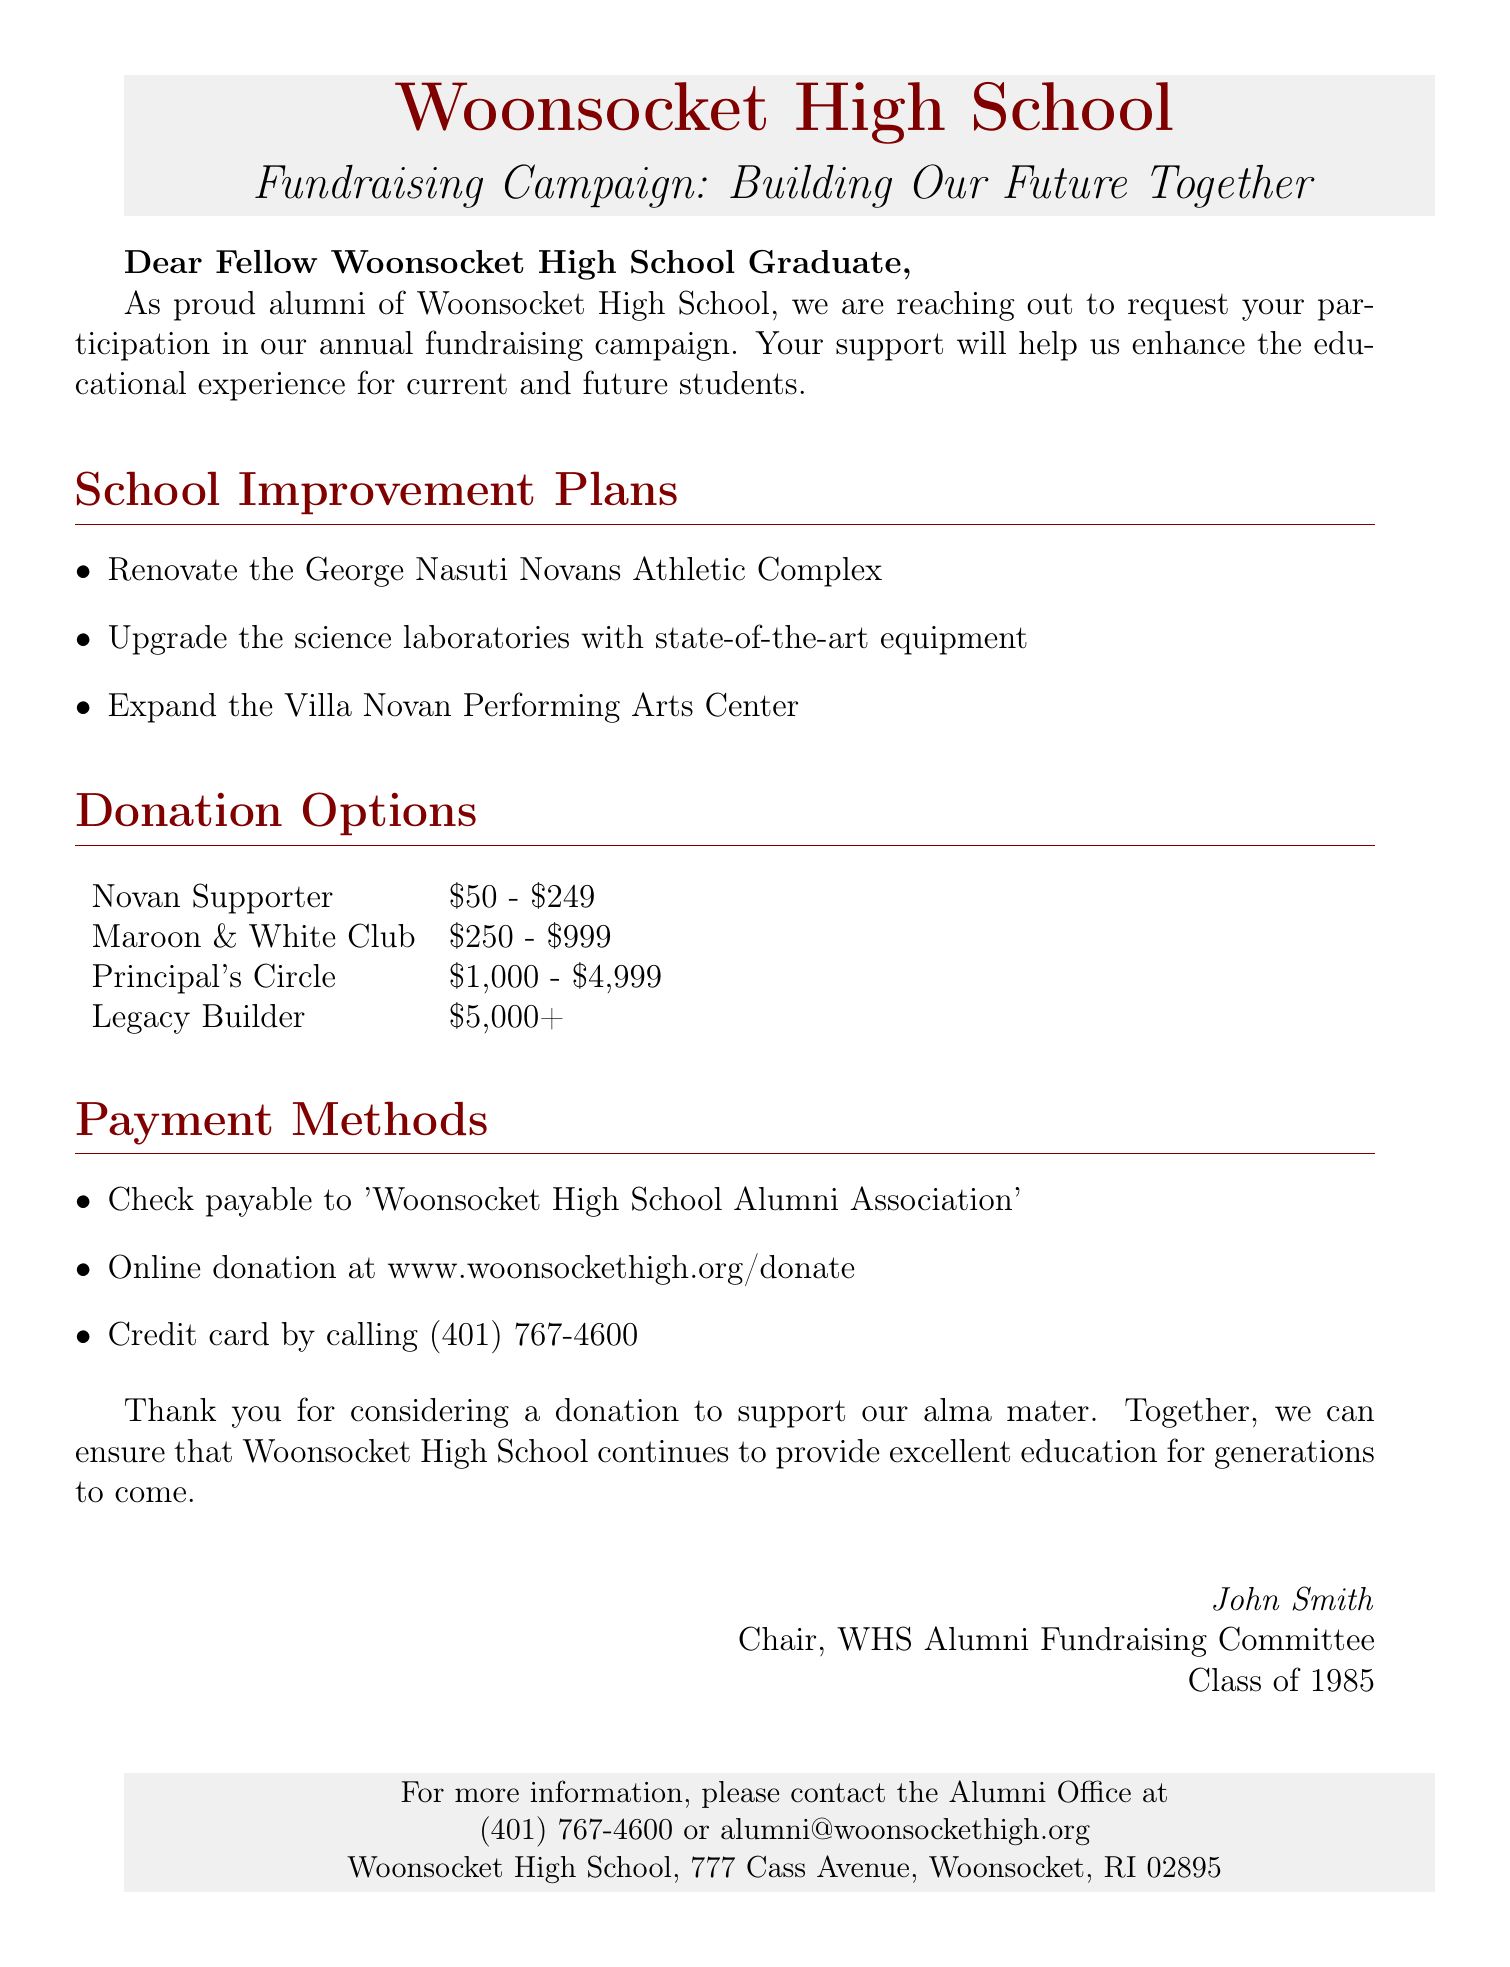What is the name of the fundraising campaign? The name of the fundraising campaign is included in the document's title section, "Building Our Future Together."
Answer: Building Our Future Together What year did John Smith graduate? The document mentions John Smith as a member of the Class of 1985, indicating his graduation year.
Answer: 1985 What is the highest donation tier? The donation options section lists the highest tier as "Legacy Builder."
Answer: Legacy Builder What is one of the school improvement plans listed? The document includes a list of school improvement plans, one of which is "Upgrade the science laboratories with state-of-the-art equipment."
Answer: Upgrade the science laboratories with state-of-the-art equipment How much is the "Maroon & White Club" donation option? The donation options specify the amount for the "Maroon & White Club" as between $250 and $999.
Answer: $250 - $999 What is the contact email for the Alumni Office? The document provides an email address for contact, which is "alumni@woonsockethigh.org."
Answer: alumni@woonsockethigh.org What payment method involves a phone call? The document states to call (401) 767-4600 for credit card donations, which indicates a payment method by phone.
Answer: Credit card by calling (401) 767-4600 